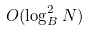Convert formula to latex. <formula><loc_0><loc_0><loc_500><loc_500>O ( \log _ { B } ^ { 2 } N )</formula> 